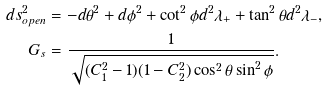<formula> <loc_0><loc_0><loc_500><loc_500>d s _ { o p e n } ^ { 2 } & = - { d \theta } ^ { 2 } + { d \phi } ^ { 2 } + \cot ^ { 2 } { \phi } d ^ { 2 } \lambda _ { + } + \tan ^ { 2 } \theta d ^ { 2 } \lambda _ { - } , \\ G _ { s } & = \frac { 1 } { \sqrt { ( C _ { 1 } ^ { 2 } - 1 ) ( 1 - C _ { 2 } ^ { 2 } ) \cos ^ { 2 } \theta \sin ^ { 2 } { \phi } } } .</formula> 